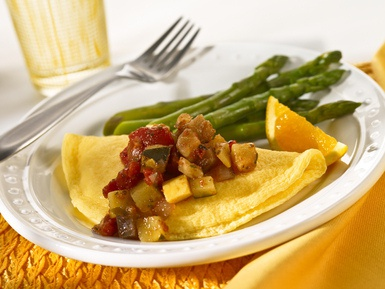Describe the objects in this image and their specific colors. I can see dining table in white, orange, tan, and olive tones, cup in white, khaki, beige, and tan tones, fork in white, darkgray, lightgray, and gray tones, and orange in white, orange, olive, and gold tones in this image. 